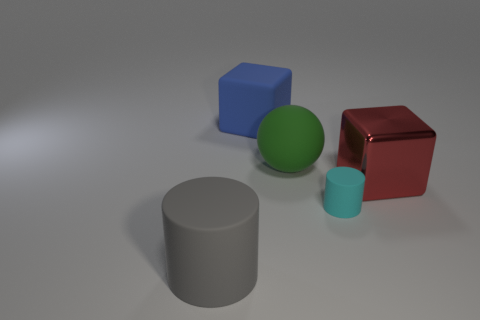Is there any other thing that is the same shape as the big green object?
Your response must be concise. No. Is there anything else that has the same size as the cyan rubber thing?
Your answer should be compact. No. The big sphere is what color?
Keep it short and to the point. Green. The thing that is left of the large cube that is left of the cylinder that is behind the big gray matte cylinder is what shape?
Provide a short and direct response. Cylinder. Are there more large objects that are behind the large ball than metal blocks to the right of the large shiny thing?
Your answer should be compact. Yes. There is a gray object; are there any tiny cyan cylinders to the right of it?
Your answer should be compact. Yes. What is the material of the large thing that is to the left of the metal cube and in front of the big green matte object?
Offer a terse response. Rubber. The other tiny rubber object that is the same shape as the gray rubber object is what color?
Make the answer very short. Cyan. There is a cylinder behind the large gray object; are there any gray cylinders behind it?
Your answer should be very brief. No. What is the size of the gray matte object?
Make the answer very short. Large. 